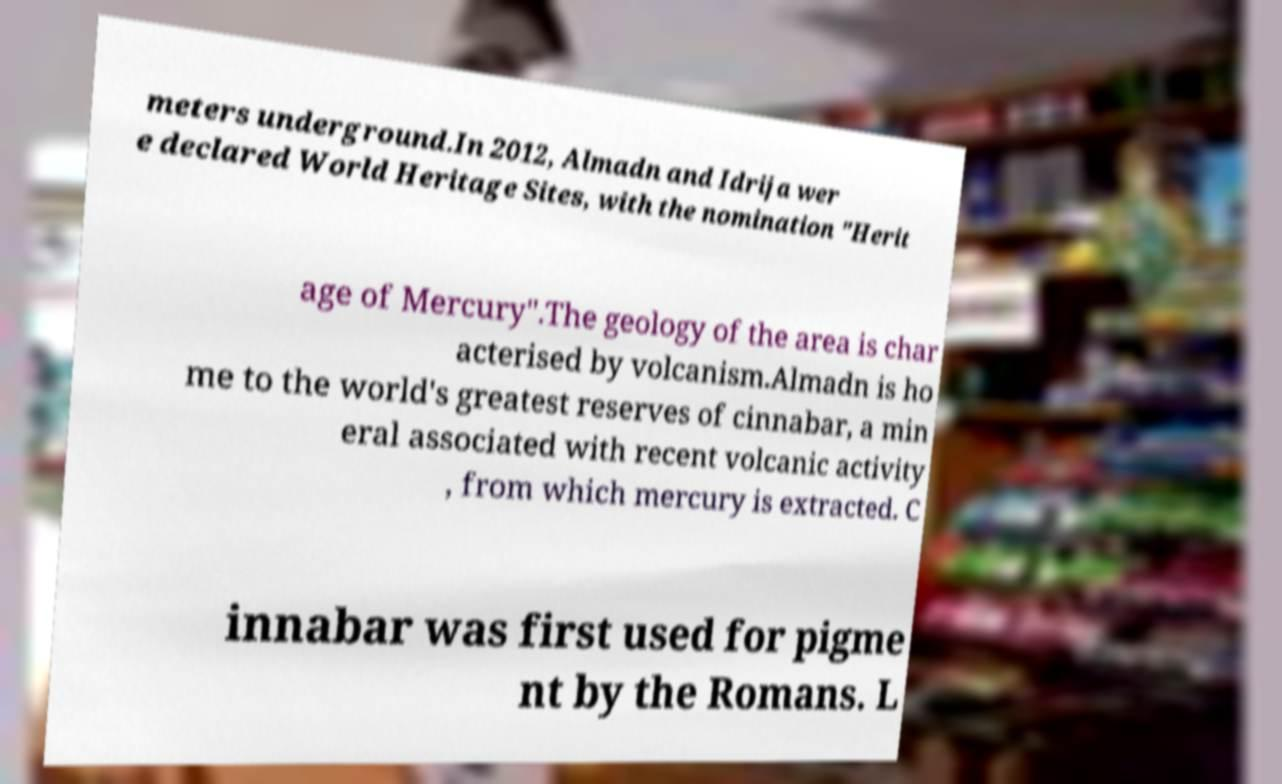Could you extract and type out the text from this image? meters underground.In 2012, Almadn and Idrija wer e declared World Heritage Sites, with the nomination "Herit age of Mercury".The geology of the area is char acterised by volcanism.Almadn is ho me to the world's greatest reserves of cinnabar, a min eral associated with recent volcanic activity , from which mercury is extracted. C innabar was first used for pigme nt by the Romans. L 